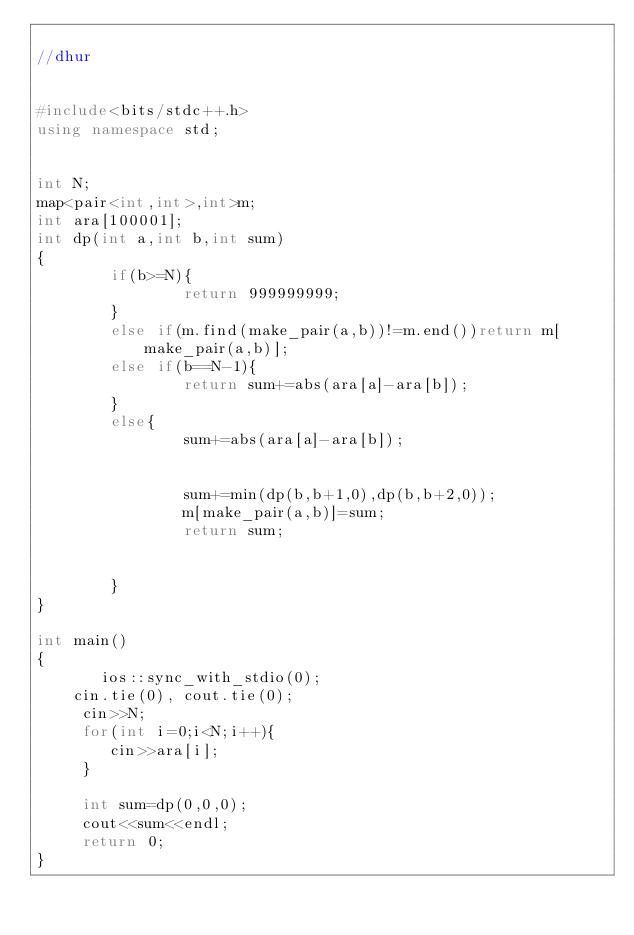Convert code to text. <code><loc_0><loc_0><loc_500><loc_500><_C++_>
//dhur


#include<bits/stdc++.h>
using namespace std;


int N;
map<pair<int,int>,int>m;
int ara[100001];
int dp(int a,int b,int sum)
{
        if(b>=N){
                return 999999999;
        }
        else if(m.find(make_pair(a,b))!=m.end())return m[make_pair(a,b)];
        else if(b==N-1){
                return sum+=abs(ara[a]-ara[b]);
        }
        else{
                sum+=abs(ara[a]-ara[b]);


                sum+=min(dp(b,b+1,0),dp(b,b+2,0));
                m[make_pair(a,b)]=sum;
                return sum;


        }
}

int main()
{
       ios::sync_with_stdio(0);
    cin.tie(0), cout.tie(0);
     cin>>N;
     for(int i=0;i<N;i++){
        cin>>ara[i];
     }

     int sum=dp(0,0,0);
     cout<<sum<<endl;
     return 0;
}
</code> 